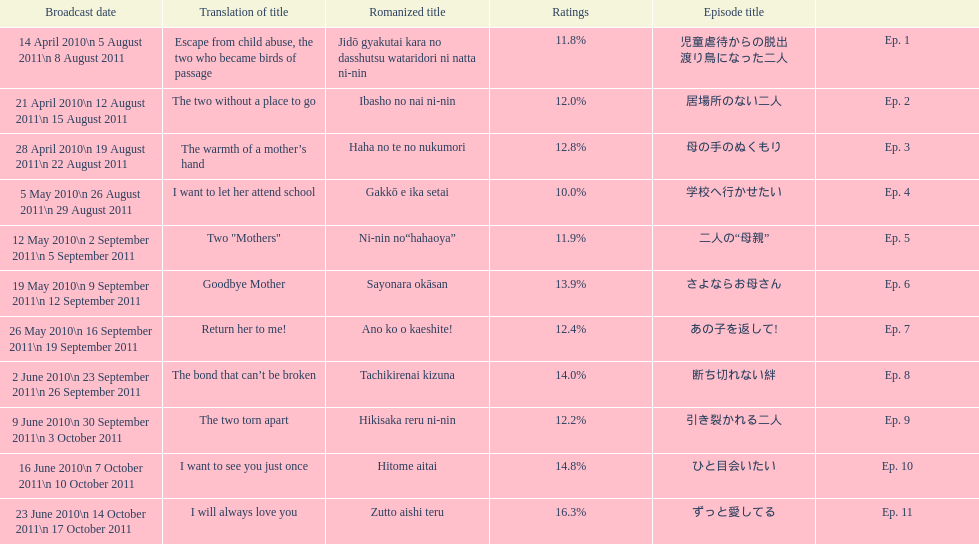How many episodes had a consecutive rating over 11%? 7. 